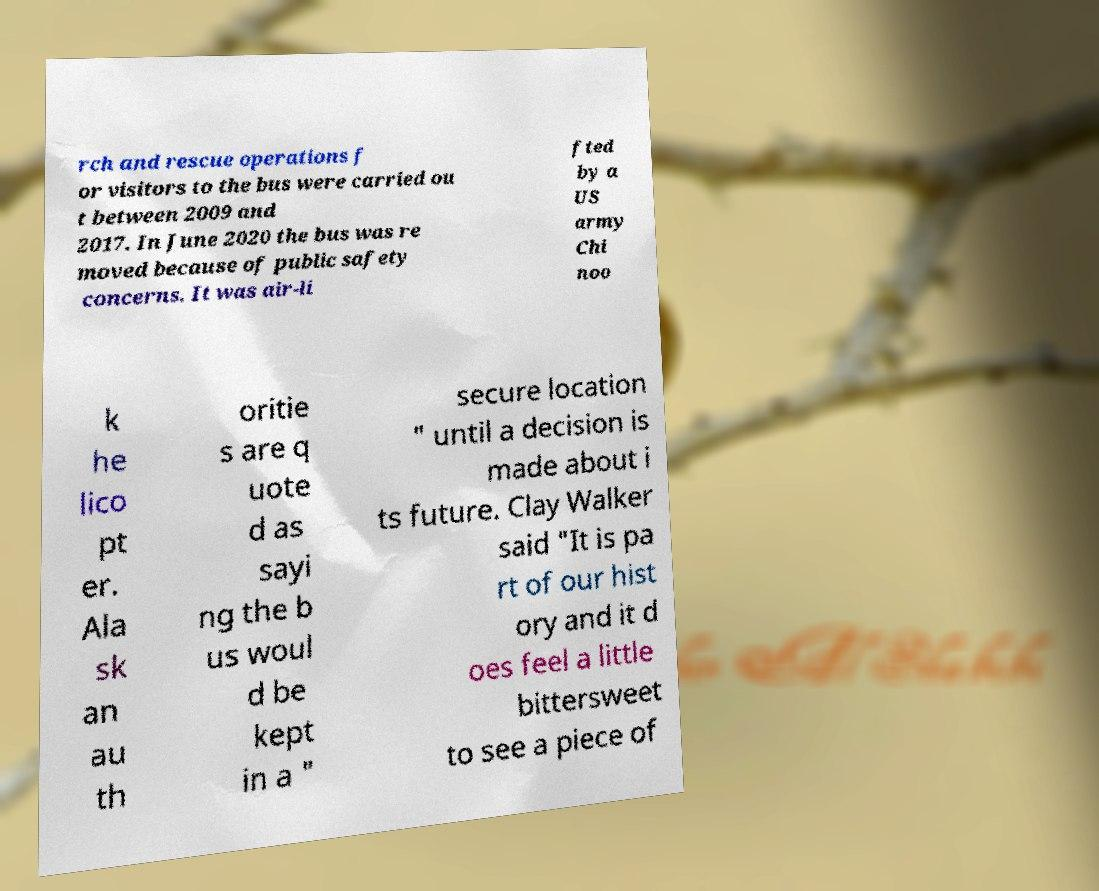What messages or text are displayed in this image? I need them in a readable, typed format. rch and rescue operations f or visitors to the bus were carried ou t between 2009 and 2017. In June 2020 the bus was re moved because of public safety concerns. It was air-li fted by a US army Chi noo k he lico pt er. Ala sk an au th oritie s are q uote d as sayi ng the b us woul d be kept in a " secure location " until a decision is made about i ts future. Clay Walker said "It is pa rt of our hist ory and it d oes feel a little bittersweet to see a piece of 